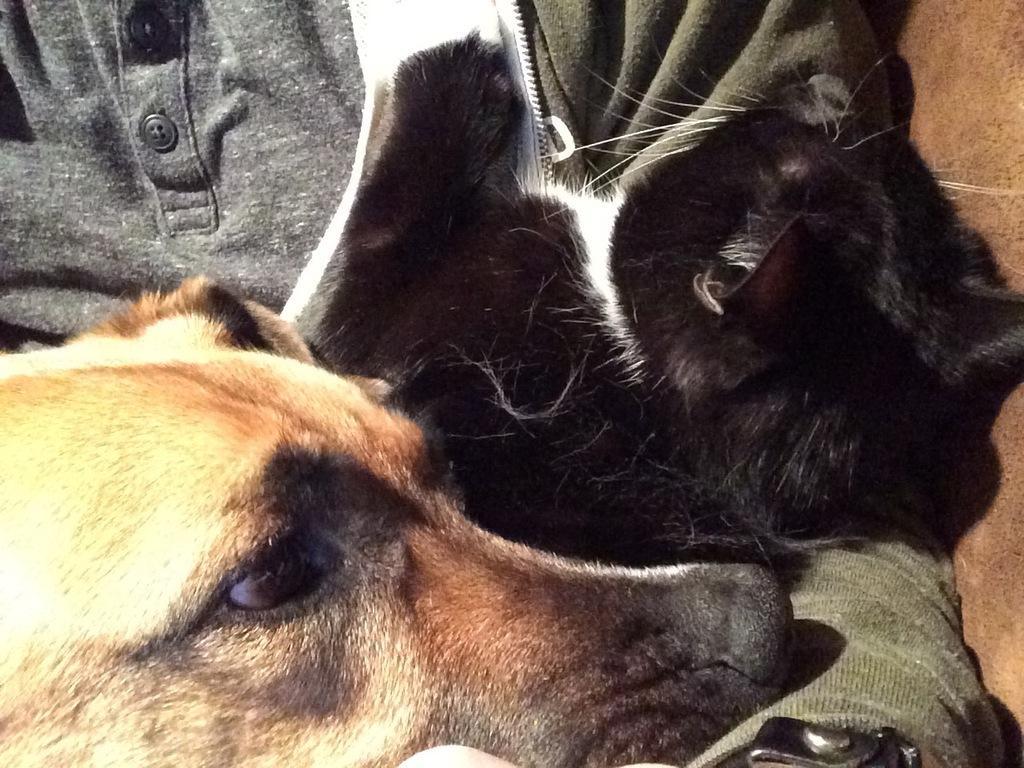Can you describe this image briefly? In this image we can see a dog and black color animal. In the background, we can see a person wearing T-shirt and jacket. 